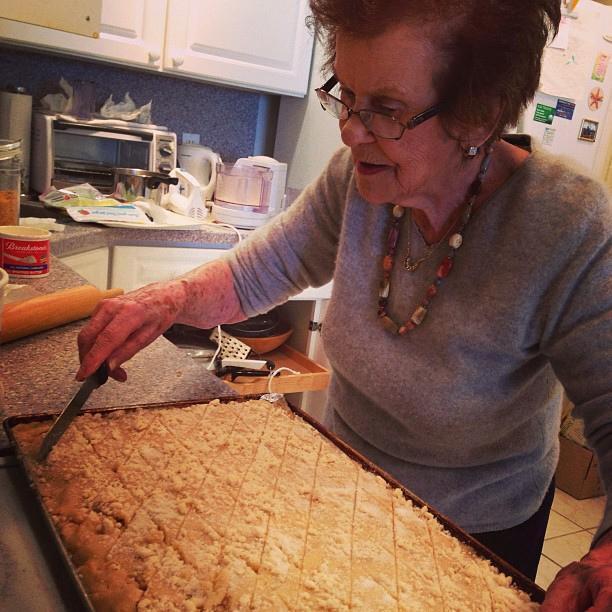What is the woman doing to her cake?
Choose the right answer and clarify with the format: 'Answer: answer
Rationale: rationale.'
Options: Stirring, freezing, puncturing, cross hatching. Answer: cross hatching.
Rationale: The woman is crosshatching. 